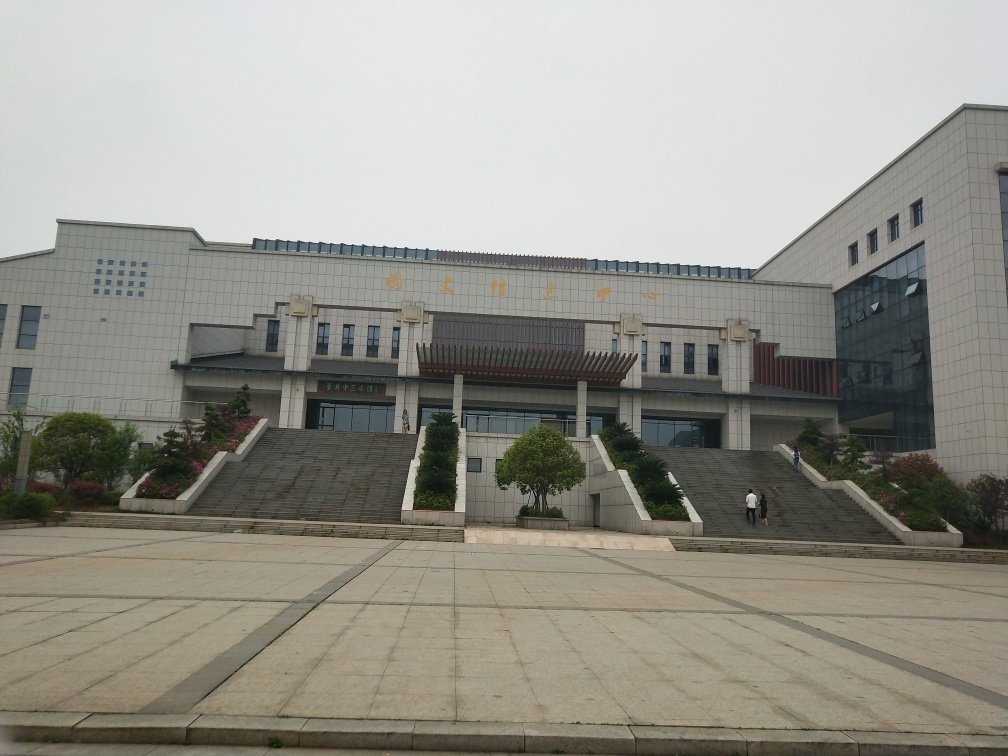What time of day and weather conditions are presented in the image? The image appears to be taken on an overcast day, given the lack of shadows and the diffused lighting. The time of day is not explicitly clear, but the absence of strong shadows suggests it could be either mid-morning or late afternoon. 